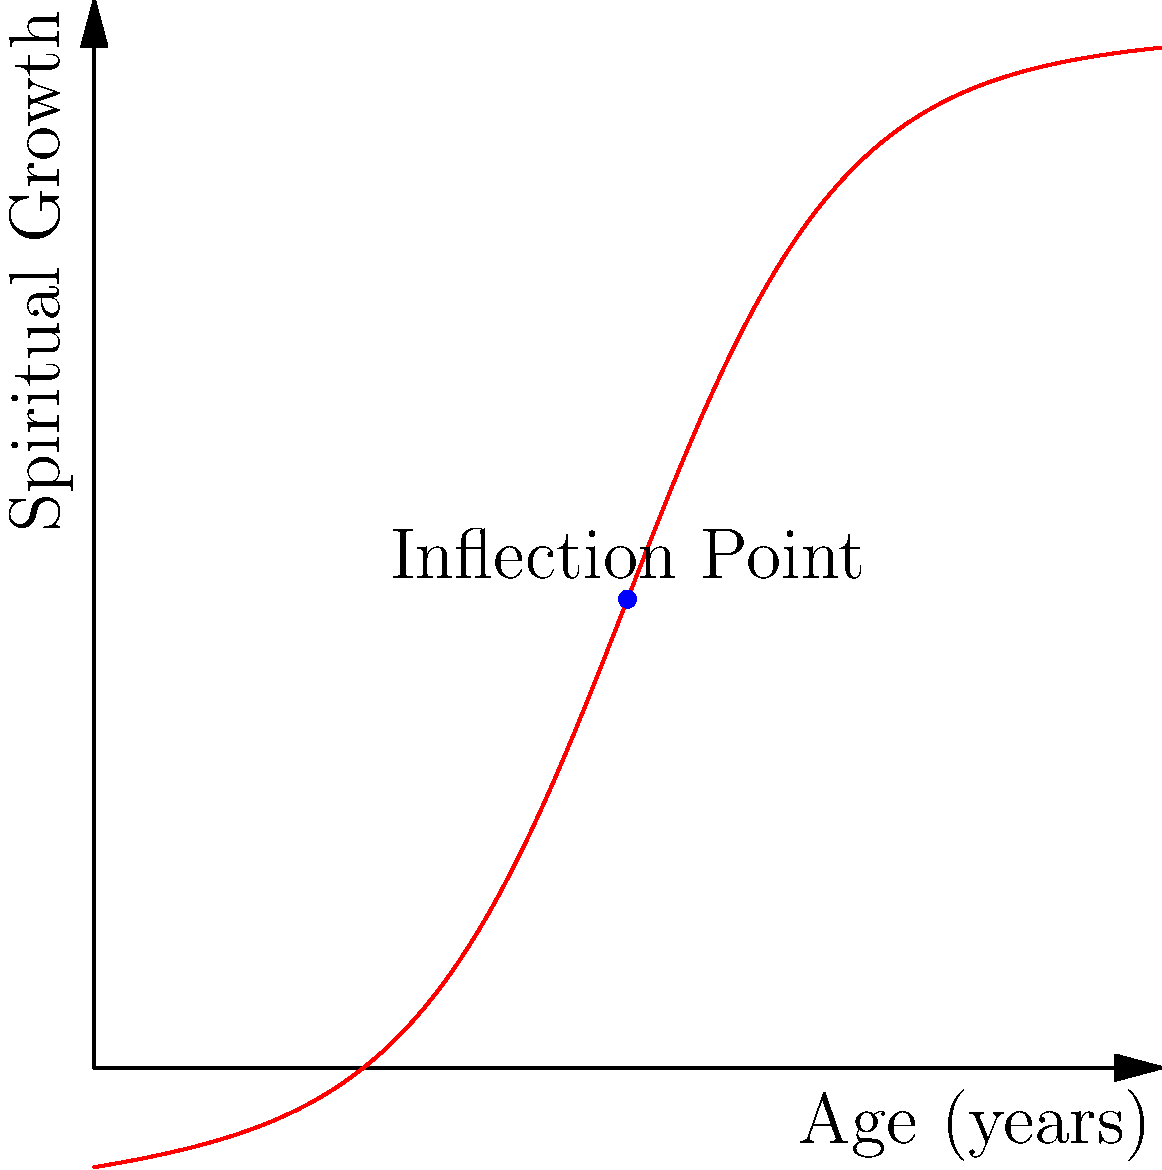In the context of spiritual development, consider the curve representing spiritual growth stages over a person's lifetime. The function modeling this growth is given by:

$$ f(x) = \frac{100}{1 + e^{-0.1(x-50)}} - 10e^{-0.01x} $$

where $x$ represents age in years and $f(x)$ represents the level of spiritual growth. Find the age at which the rate of spiritual growth is changing most rapidly (i.e., the inflection point of the curve). To find the inflection point, we need to follow these steps:

1) The inflection point occurs where the second derivative of the function equals zero. So, we need to find $f''(x)$ and set it to zero.

2) First, let's find $f'(x)$:
   $$ f'(x) = \frac{10e^{-0.1(x-50)}}{(1 + e^{-0.1(x-50)})^2} + 0.1e^{-0.01x} $$

3) Now, let's find $f''(x)$:
   $$ f''(x) = \frac{10e^{-0.1(x-50)}(1 + e^{-0.1(x-50)})(-0.1) - 20e^{-0.2(x-50)}}{(1 + e^{-0.1(x-50)})^3} - 0.001e^{-0.01x} $$

4) Setting $f''(x) = 0$ and solving for $x$ analytically is complex. However, due to the symmetry of the logistic part of the function and the relatively small impact of the exponential decay term, we can deduce that the inflection point occurs very close to $x = 50$.

5) This can be verified numerically or by observing the graph, where we see the curve has its steepest slope (and thus, the rate of change is changing most rapidly) at $x = 50$.

6) From a psychological and spiritual perspective, this inflection point at age 50 could represent a significant turning point in one's spiritual journey, perhaps correlating with increased wisdom, life experience, and a deeper understanding of one's faith.
Answer: 50 years 